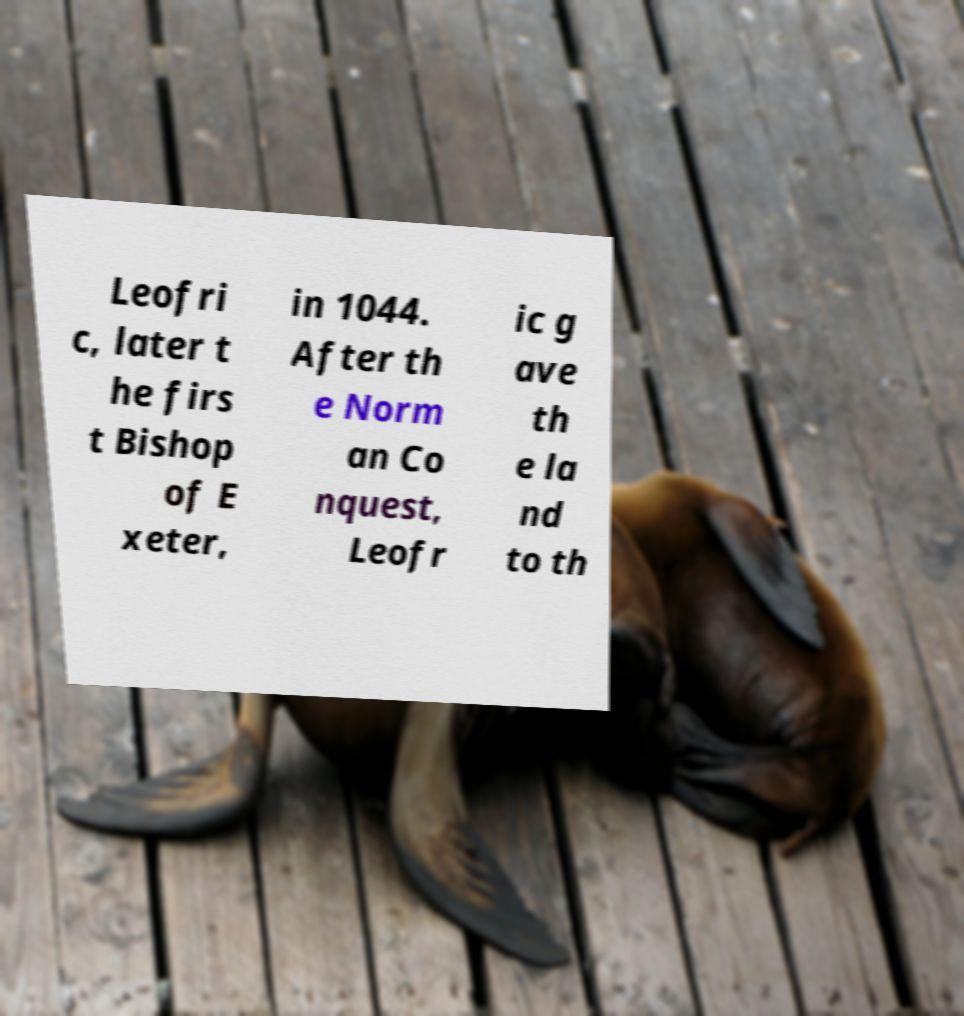Please read and relay the text visible in this image. What does it say? Leofri c, later t he firs t Bishop of E xeter, in 1044. After th e Norm an Co nquest, Leofr ic g ave th e la nd to th 